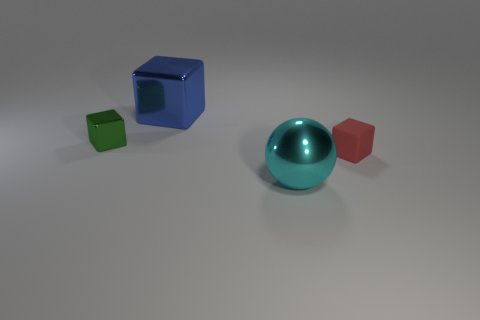What color is the large ball that is made of the same material as the small green object?
Provide a short and direct response. Cyan. Is there a cyan matte object that has the same size as the metal sphere?
Make the answer very short. No. Are there more small cubes that are right of the blue block than green shiny things behind the green object?
Provide a short and direct response. Yes. Do the thing that is on the left side of the big blue shiny thing and the thing that is behind the green shiny object have the same material?
Make the answer very short. Yes. What shape is the red rubber object that is the same size as the green object?
Give a very brief answer. Cube. Is there a rubber object that has the same shape as the tiny shiny object?
Your response must be concise. Yes. Are there any blue cubes right of the red rubber cube?
Keep it short and to the point. No. There is a block that is in front of the large blue metallic thing and behind the tiny rubber thing; what material is it made of?
Provide a succinct answer. Metal. Are the small thing that is left of the tiny red object and the tiny red thing made of the same material?
Keep it short and to the point. No. What is the material of the red block?
Provide a short and direct response. Rubber. 